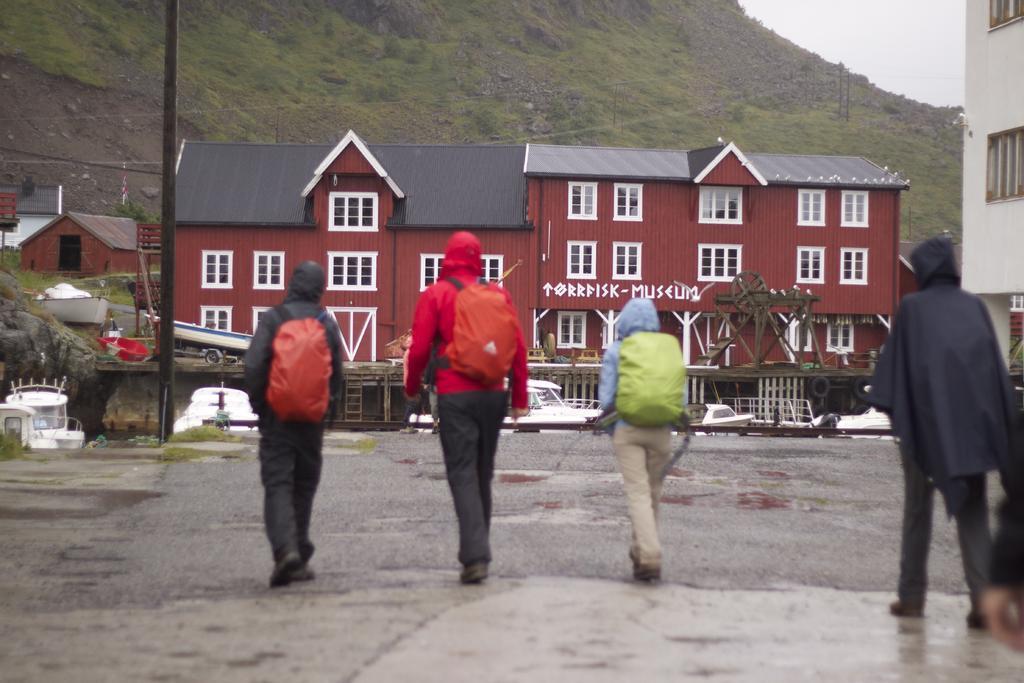In one or two sentences, can you explain what this image depicts? In this picture, there are three people on the road. All of them wearing jackets and carrying bags, they are facing backwards. Towards the right, there is another person. In the background, there are houses, hills, plants, sky etc. 